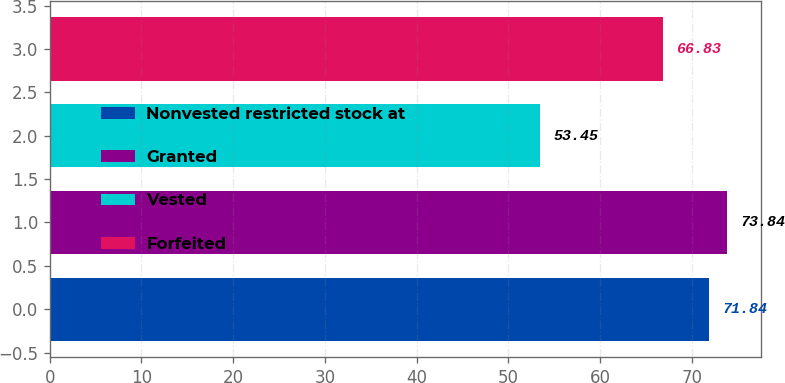Convert chart to OTSL. <chart><loc_0><loc_0><loc_500><loc_500><bar_chart><fcel>Nonvested restricted stock at<fcel>Granted<fcel>Vested<fcel>Forfeited<nl><fcel>71.84<fcel>73.84<fcel>53.45<fcel>66.83<nl></chart> 